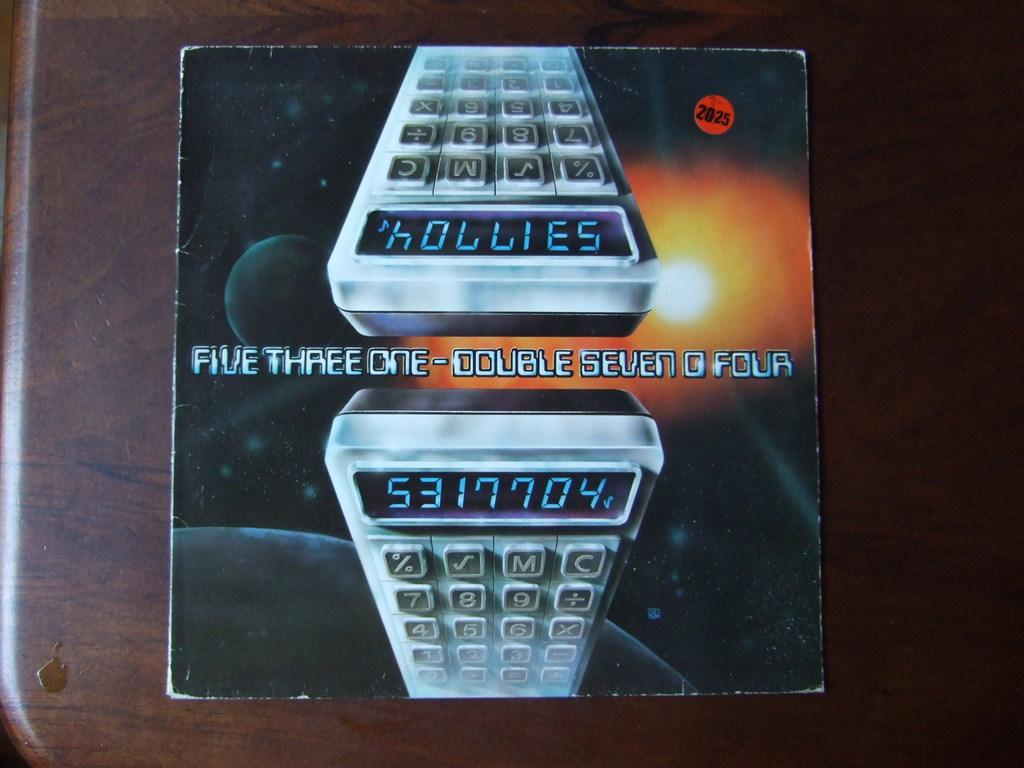<image>
Present a compact description of the photo's key features. An album cover that says Five Three One - Double Seven O Four. 